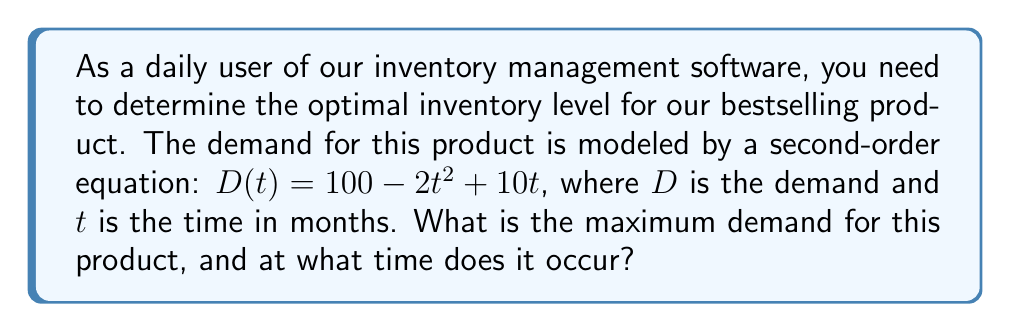Show me your answer to this math problem. To find the maximum demand and the time it occurs, we need to follow these steps:

1) The demand function is given by:
   $$D(t) = 100 - 2t^2 + 10t$$

2) To find the maximum, we need to find where the derivative of this function equals zero. Let's first find the derivative:
   $$D'(t) = -4t + 10$$

3) Set this equal to zero and solve for t:
   $$-4t + 10 = 0$$
   $$-4t = -10$$
   $$t = \frac{10}{4} = 2.5$$

4) To confirm this is a maximum (not a minimum), we can check the second derivative:
   $$D''(t) = -4$$
   Since this is negative, we confirm that $t = 2.5$ gives us a maximum.

5) Now, let's calculate the maximum demand by plugging $t = 2.5$ into our original equation:
   $$D(2.5) = 100 - 2(2.5)^2 + 10(2.5)$$
   $$= 100 - 2(6.25) + 25$$
   $$= 100 - 12.5 + 25$$
   $$= 112.5$$

Therefore, the maximum demand occurs at 2.5 months and the demand at this point is 112.5 units.
Answer: The maximum demand is 112.5 units, occurring at 2.5 months. 